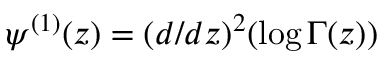<formula> <loc_0><loc_0><loc_500><loc_500>\psi ^ { ( 1 ) } ( z ) = ( d / d z ) ^ { 2 } ( \log \Gamma ( z ) )</formula> 